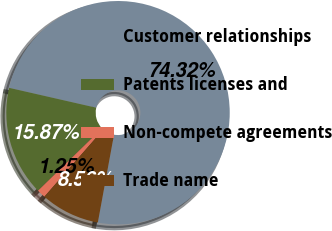Convert chart to OTSL. <chart><loc_0><loc_0><loc_500><loc_500><pie_chart><fcel>Customer relationships<fcel>Patents licenses and<fcel>Non-compete agreements<fcel>Trade name<nl><fcel>74.33%<fcel>15.87%<fcel>1.25%<fcel>8.56%<nl></chart> 